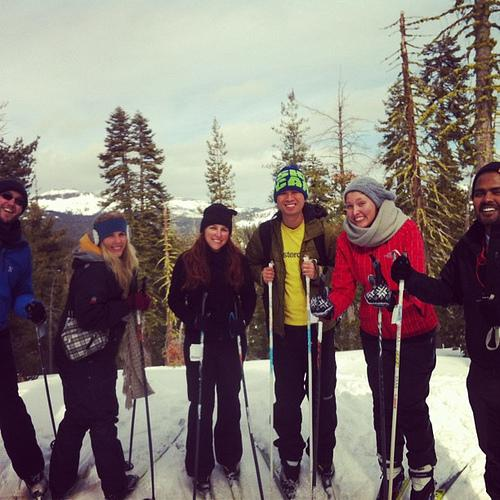Question: what color is the snow?
Choices:
A. Brown.
B. Yellow.
C. White.
D. Black.
Answer with the letter. Answer: C Question: where are they?
Choices:
A. Beach.
B. Ski slope.
C. Forest.
D. Mall.
Answer with the letter. Answer: B Question: what are they standing in?
Choices:
A. Water.
B. Snow.
C. Mud.
D. Grass.
Answer with the letter. Answer: B Question: how many people are shown?
Choices:
A. One.
B. Two.
C. Three.
D. Six.
Answer with the letter. Answer: D Question: how many girls are there?
Choices:
A. Four.
B. Two.
C. Three.
D. Five.
Answer with the letter. Answer: C Question: what is everyone holding?
Choices:
A. Sticks.
B. Skiis.
C. Ski poles.
D. Surfboards.
Answer with the letter. Answer: C 